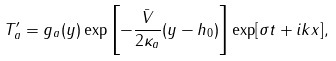<formula> <loc_0><loc_0><loc_500><loc_500>T ^ { \prime } _ { a } = g _ { a } ( y ) \exp \left [ - \frac { \bar { V } } { 2 \kappa _ { a } } ( y - h _ { 0 } ) \right ] \exp [ \sigma t + i k x ] ,</formula> 